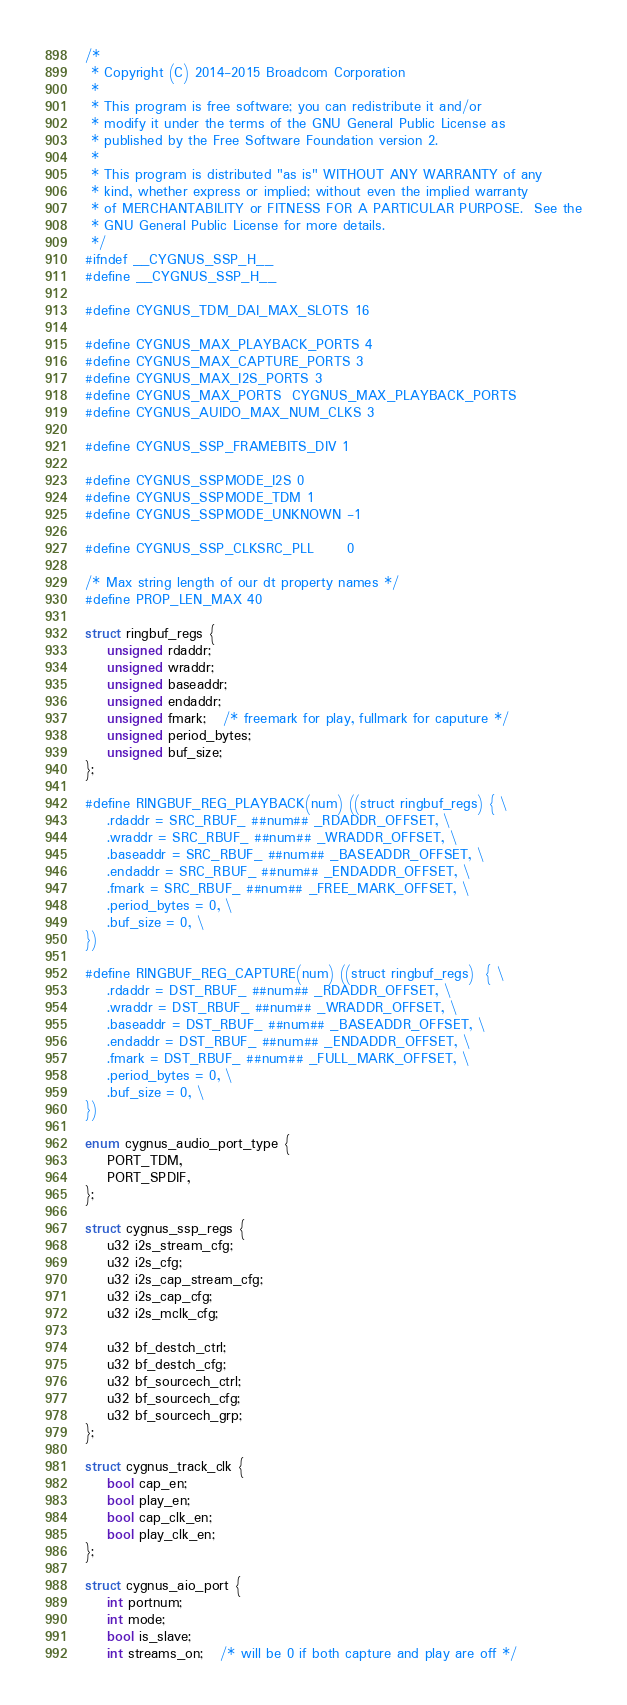<code> <loc_0><loc_0><loc_500><loc_500><_C_>/*
 * Copyright (C) 2014-2015 Broadcom Corporation
 *
 * This program is free software; you can redistribute it and/or
 * modify it under the terms of the GNU General Public License as
 * published by the Free Software Foundation version 2.
 *
 * This program is distributed "as is" WITHOUT ANY WARRANTY of any
 * kind, whether express or implied; without even the implied warranty
 * of MERCHANTABILITY or FITNESS FOR A PARTICULAR PURPOSE.  See the
 * GNU General Public License for more details.
 */
#ifndef __CYGNUS_SSP_H__
#define __CYGNUS_SSP_H__

#define CYGNUS_TDM_DAI_MAX_SLOTS 16

#define CYGNUS_MAX_PLAYBACK_PORTS 4
#define CYGNUS_MAX_CAPTURE_PORTS 3
#define CYGNUS_MAX_I2S_PORTS 3
#define CYGNUS_MAX_PORTS  CYGNUS_MAX_PLAYBACK_PORTS
#define CYGNUS_AUIDO_MAX_NUM_CLKS 3

#define CYGNUS_SSP_FRAMEBITS_DIV 1

#define CYGNUS_SSPMODE_I2S 0
#define CYGNUS_SSPMODE_TDM 1
#define CYGNUS_SSPMODE_UNKNOWN -1

#define CYGNUS_SSP_CLKSRC_PLL      0

/* Max string length of our dt property names */
#define PROP_LEN_MAX 40

struct ringbuf_regs {
	unsigned rdaddr;
	unsigned wraddr;
	unsigned baseaddr;
	unsigned endaddr;
	unsigned fmark;   /* freemark for play, fullmark for caputure */
	unsigned period_bytes;
	unsigned buf_size;
};

#define RINGBUF_REG_PLAYBACK(num) ((struct ringbuf_regs) { \
	.rdaddr = SRC_RBUF_ ##num## _RDADDR_OFFSET, \
	.wraddr = SRC_RBUF_ ##num## _WRADDR_OFFSET, \
	.baseaddr = SRC_RBUF_ ##num## _BASEADDR_OFFSET, \
	.endaddr = SRC_RBUF_ ##num## _ENDADDR_OFFSET, \
	.fmark = SRC_RBUF_ ##num## _FREE_MARK_OFFSET, \
	.period_bytes = 0, \
	.buf_size = 0, \
})

#define RINGBUF_REG_CAPTURE(num) ((struct ringbuf_regs)  { \
	.rdaddr = DST_RBUF_ ##num## _RDADDR_OFFSET, \
	.wraddr = DST_RBUF_ ##num## _WRADDR_OFFSET, \
	.baseaddr = DST_RBUF_ ##num## _BASEADDR_OFFSET, \
	.endaddr = DST_RBUF_ ##num## _ENDADDR_OFFSET, \
	.fmark = DST_RBUF_ ##num## _FULL_MARK_OFFSET, \
	.period_bytes = 0, \
	.buf_size = 0, \
})

enum cygnus_audio_port_type {
	PORT_TDM,
	PORT_SPDIF,
};

struct cygnus_ssp_regs {
	u32 i2s_stream_cfg;
	u32 i2s_cfg;
	u32 i2s_cap_stream_cfg;
	u32 i2s_cap_cfg;
	u32 i2s_mclk_cfg;

	u32 bf_destch_ctrl;
	u32 bf_destch_cfg;
	u32 bf_sourcech_ctrl;
	u32 bf_sourcech_cfg;
	u32 bf_sourcech_grp;
};

struct cygnus_track_clk {
	bool cap_en;
	bool play_en;
	bool cap_clk_en;
	bool play_clk_en;
};

struct cygnus_aio_port {
	int portnum;
	int mode;
	bool is_slave;
	int streams_on;   /* will be 0 if both capture and play are off */</code> 